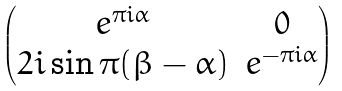<formula> <loc_0><loc_0><loc_500><loc_500>\begin{pmatrix} e ^ { \pi i \alpha } & 0 \\ 2 i \sin \pi ( \beta - \alpha ) & e ^ { - \pi i \alpha } \end{pmatrix}</formula> 